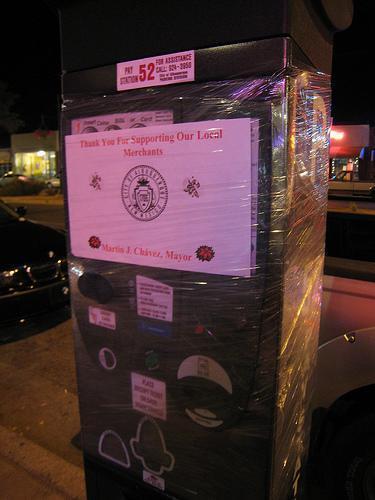How many cars are on the same side of the road as the playstation?
Give a very brief answer. 2. 